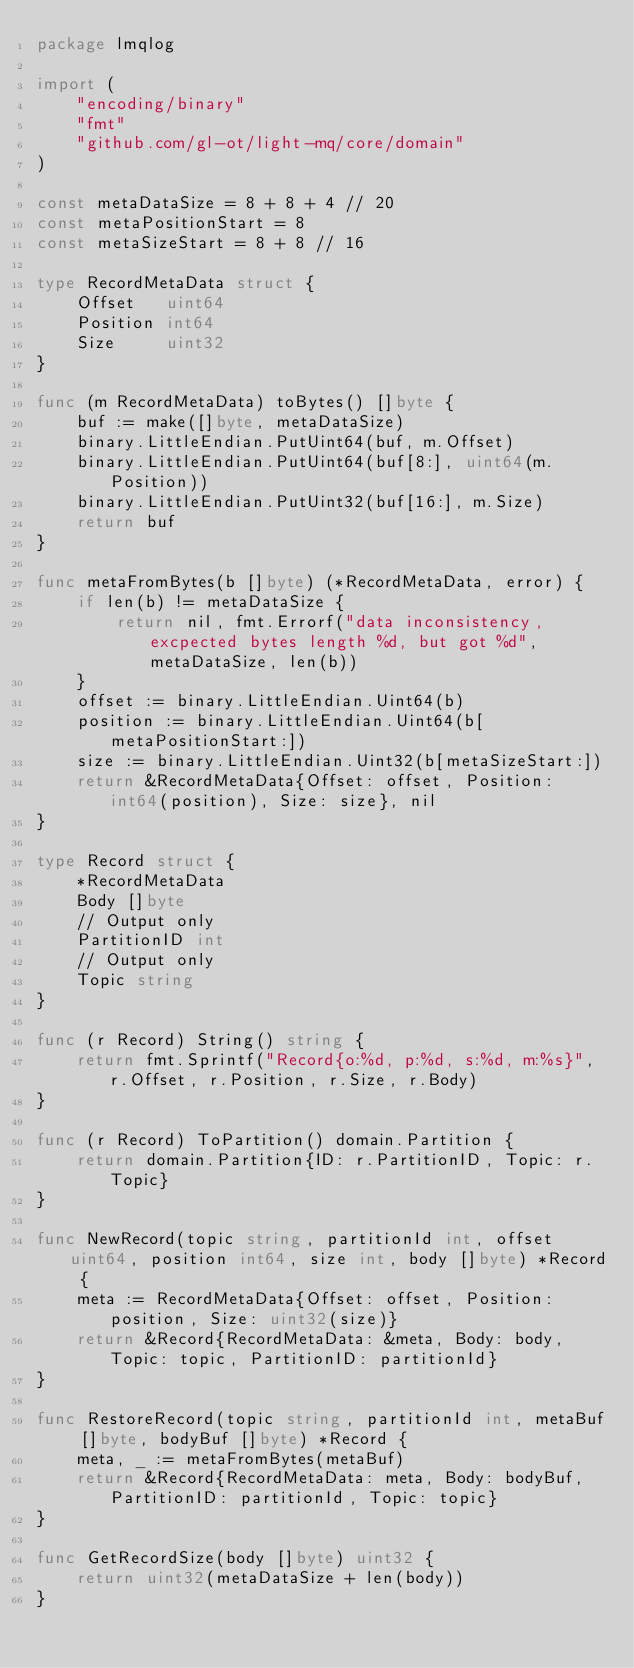<code> <loc_0><loc_0><loc_500><loc_500><_Go_>package lmqlog

import (
	"encoding/binary"
	"fmt"
	"github.com/gl-ot/light-mq/core/domain"
)

const metaDataSize = 8 + 8 + 4 // 20
const metaPositionStart = 8
const metaSizeStart = 8 + 8 // 16

type RecordMetaData struct {
	Offset   uint64
	Position int64
	Size     uint32
}

func (m RecordMetaData) toBytes() []byte {
	buf := make([]byte, metaDataSize)
	binary.LittleEndian.PutUint64(buf, m.Offset)
	binary.LittleEndian.PutUint64(buf[8:], uint64(m.Position))
	binary.LittleEndian.PutUint32(buf[16:], m.Size)
	return buf
}

func metaFromBytes(b []byte) (*RecordMetaData, error) {
	if len(b) != metaDataSize {
		return nil, fmt.Errorf("data inconsistency, excpected bytes length %d, but got %d", metaDataSize, len(b))
	}
	offset := binary.LittleEndian.Uint64(b)
	position := binary.LittleEndian.Uint64(b[metaPositionStart:])
	size := binary.LittleEndian.Uint32(b[metaSizeStart:])
	return &RecordMetaData{Offset: offset, Position: int64(position), Size: size}, nil
}

type Record struct {
	*RecordMetaData
	Body []byte
	// Output only
	PartitionID int
	// Output only
	Topic string
}

func (r Record) String() string {
	return fmt.Sprintf("Record{o:%d, p:%d, s:%d, m:%s}", r.Offset, r.Position, r.Size, r.Body)
}

func (r Record) ToPartition() domain.Partition {
	return domain.Partition{ID: r.PartitionID, Topic: r.Topic}
}

func NewRecord(topic string, partitionId int, offset uint64, position int64, size int, body []byte) *Record {
	meta := RecordMetaData{Offset: offset, Position: position, Size: uint32(size)}
	return &Record{RecordMetaData: &meta, Body: body, Topic: topic, PartitionID: partitionId}
}

func RestoreRecord(topic string, partitionId int, metaBuf []byte, bodyBuf []byte) *Record {
	meta, _ := metaFromBytes(metaBuf)
	return &Record{RecordMetaData: meta, Body: bodyBuf, PartitionID: partitionId, Topic: topic}
}

func GetRecordSize(body []byte) uint32 {
	return uint32(metaDataSize + len(body))
}
</code> 